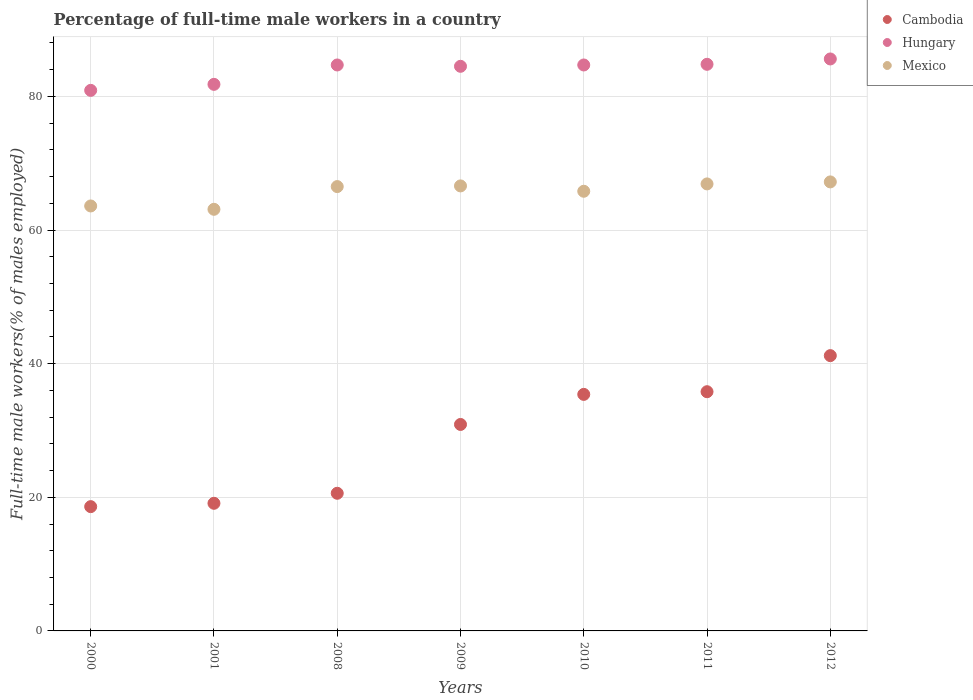Is the number of dotlines equal to the number of legend labels?
Your answer should be compact. Yes. What is the percentage of full-time male workers in Hungary in 2010?
Provide a short and direct response. 84.7. Across all years, what is the maximum percentage of full-time male workers in Cambodia?
Make the answer very short. 41.2. Across all years, what is the minimum percentage of full-time male workers in Mexico?
Keep it short and to the point. 63.1. What is the total percentage of full-time male workers in Mexico in the graph?
Provide a short and direct response. 459.7. What is the difference between the percentage of full-time male workers in Hungary in 2009 and that in 2012?
Your response must be concise. -1.1. What is the difference between the percentage of full-time male workers in Hungary in 2012 and the percentage of full-time male workers in Cambodia in 2008?
Keep it short and to the point. 65. What is the average percentage of full-time male workers in Mexico per year?
Provide a succinct answer. 65.67. In the year 2010, what is the difference between the percentage of full-time male workers in Hungary and percentage of full-time male workers in Cambodia?
Make the answer very short. 49.3. In how many years, is the percentage of full-time male workers in Hungary greater than 32 %?
Ensure brevity in your answer.  7. What is the ratio of the percentage of full-time male workers in Cambodia in 2008 to that in 2012?
Your response must be concise. 0.5. Is the percentage of full-time male workers in Mexico in 2009 less than that in 2012?
Provide a short and direct response. Yes. What is the difference between the highest and the second highest percentage of full-time male workers in Hungary?
Ensure brevity in your answer.  0.8. What is the difference between the highest and the lowest percentage of full-time male workers in Cambodia?
Your answer should be very brief. 22.6. Does the percentage of full-time male workers in Cambodia monotonically increase over the years?
Ensure brevity in your answer.  Yes. Is the percentage of full-time male workers in Hungary strictly less than the percentage of full-time male workers in Cambodia over the years?
Ensure brevity in your answer.  No. Are the values on the major ticks of Y-axis written in scientific E-notation?
Offer a terse response. No. Does the graph contain any zero values?
Offer a very short reply. No. What is the title of the graph?
Give a very brief answer. Percentage of full-time male workers in a country. What is the label or title of the Y-axis?
Make the answer very short. Full-time male workers(% of males employed). What is the Full-time male workers(% of males employed) in Cambodia in 2000?
Offer a very short reply. 18.6. What is the Full-time male workers(% of males employed) in Hungary in 2000?
Your response must be concise. 80.9. What is the Full-time male workers(% of males employed) in Mexico in 2000?
Provide a succinct answer. 63.6. What is the Full-time male workers(% of males employed) of Cambodia in 2001?
Keep it short and to the point. 19.1. What is the Full-time male workers(% of males employed) of Hungary in 2001?
Offer a very short reply. 81.8. What is the Full-time male workers(% of males employed) of Mexico in 2001?
Give a very brief answer. 63.1. What is the Full-time male workers(% of males employed) in Cambodia in 2008?
Offer a very short reply. 20.6. What is the Full-time male workers(% of males employed) of Hungary in 2008?
Provide a succinct answer. 84.7. What is the Full-time male workers(% of males employed) in Mexico in 2008?
Your answer should be very brief. 66.5. What is the Full-time male workers(% of males employed) in Cambodia in 2009?
Offer a terse response. 30.9. What is the Full-time male workers(% of males employed) in Hungary in 2009?
Your answer should be very brief. 84.5. What is the Full-time male workers(% of males employed) in Mexico in 2009?
Keep it short and to the point. 66.6. What is the Full-time male workers(% of males employed) of Cambodia in 2010?
Make the answer very short. 35.4. What is the Full-time male workers(% of males employed) in Hungary in 2010?
Provide a succinct answer. 84.7. What is the Full-time male workers(% of males employed) of Mexico in 2010?
Ensure brevity in your answer.  65.8. What is the Full-time male workers(% of males employed) in Cambodia in 2011?
Your answer should be compact. 35.8. What is the Full-time male workers(% of males employed) of Hungary in 2011?
Your response must be concise. 84.8. What is the Full-time male workers(% of males employed) in Mexico in 2011?
Give a very brief answer. 66.9. What is the Full-time male workers(% of males employed) in Cambodia in 2012?
Keep it short and to the point. 41.2. What is the Full-time male workers(% of males employed) in Hungary in 2012?
Ensure brevity in your answer.  85.6. What is the Full-time male workers(% of males employed) in Mexico in 2012?
Provide a short and direct response. 67.2. Across all years, what is the maximum Full-time male workers(% of males employed) in Cambodia?
Offer a very short reply. 41.2. Across all years, what is the maximum Full-time male workers(% of males employed) of Hungary?
Ensure brevity in your answer.  85.6. Across all years, what is the maximum Full-time male workers(% of males employed) in Mexico?
Provide a short and direct response. 67.2. Across all years, what is the minimum Full-time male workers(% of males employed) in Cambodia?
Offer a very short reply. 18.6. Across all years, what is the minimum Full-time male workers(% of males employed) of Hungary?
Offer a terse response. 80.9. Across all years, what is the minimum Full-time male workers(% of males employed) in Mexico?
Ensure brevity in your answer.  63.1. What is the total Full-time male workers(% of males employed) in Cambodia in the graph?
Provide a short and direct response. 201.6. What is the total Full-time male workers(% of males employed) of Hungary in the graph?
Provide a short and direct response. 587. What is the total Full-time male workers(% of males employed) of Mexico in the graph?
Offer a terse response. 459.7. What is the difference between the Full-time male workers(% of males employed) in Cambodia in 2000 and that in 2001?
Your answer should be very brief. -0.5. What is the difference between the Full-time male workers(% of males employed) of Mexico in 2000 and that in 2001?
Ensure brevity in your answer.  0.5. What is the difference between the Full-time male workers(% of males employed) in Cambodia in 2000 and that in 2008?
Your answer should be very brief. -2. What is the difference between the Full-time male workers(% of males employed) of Hungary in 2000 and that in 2008?
Give a very brief answer. -3.8. What is the difference between the Full-time male workers(% of males employed) of Mexico in 2000 and that in 2008?
Give a very brief answer. -2.9. What is the difference between the Full-time male workers(% of males employed) of Cambodia in 2000 and that in 2009?
Keep it short and to the point. -12.3. What is the difference between the Full-time male workers(% of males employed) in Cambodia in 2000 and that in 2010?
Offer a terse response. -16.8. What is the difference between the Full-time male workers(% of males employed) in Hungary in 2000 and that in 2010?
Your answer should be compact. -3.8. What is the difference between the Full-time male workers(% of males employed) of Cambodia in 2000 and that in 2011?
Your answer should be compact. -17.2. What is the difference between the Full-time male workers(% of males employed) in Hungary in 2000 and that in 2011?
Give a very brief answer. -3.9. What is the difference between the Full-time male workers(% of males employed) of Mexico in 2000 and that in 2011?
Offer a very short reply. -3.3. What is the difference between the Full-time male workers(% of males employed) in Cambodia in 2000 and that in 2012?
Give a very brief answer. -22.6. What is the difference between the Full-time male workers(% of males employed) of Mexico in 2000 and that in 2012?
Your answer should be compact. -3.6. What is the difference between the Full-time male workers(% of males employed) of Hungary in 2001 and that in 2008?
Provide a short and direct response. -2.9. What is the difference between the Full-time male workers(% of males employed) of Mexico in 2001 and that in 2009?
Provide a short and direct response. -3.5. What is the difference between the Full-time male workers(% of males employed) in Cambodia in 2001 and that in 2010?
Offer a terse response. -16.3. What is the difference between the Full-time male workers(% of males employed) in Hungary in 2001 and that in 2010?
Ensure brevity in your answer.  -2.9. What is the difference between the Full-time male workers(% of males employed) of Cambodia in 2001 and that in 2011?
Your answer should be compact. -16.7. What is the difference between the Full-time male workers(% of males employed) of Mexico in 2001 and that in 2011?
Your answer should be very brief. -3.8. What is the difference between the Full-time male workers(% of males employed) of Cambodia in 2001 and that in 2012?
Provide a succinct answer. -22.1. What is the difference between the Full-time male workers(% of males employed) in Hungary in 2001 and that in 2012?
Provide a succinct answer. -3.8. What is the difference between the Full-time male workers(% of males employed) of Mexico in 2001 and that in 2012?
Your answer should be very brief. -4.1. What is the difference between the Full-time male workers(% of males employed) in Cambodia in 2008 and that in 2010?
Give a very brief answer. -14.8. What is the difference between the Full-time male workers(% of males employed) in Hungary in 2008 and that in 2010?
Your answer should be very brief. 0. What is the difference between the Full-time male workers(% of males employed) in Cambodia in 2008 and that in 2011?
Offer a very short reply. -15.2. What is the difference between the Full-time male workers(% of males employed) in Hungary in 2008 and that in 2011?
Ensure brevity in your answer.  -0.1. What is the difference between the Full-time male workers(% of males employed) of Mexico in 2008 and that in 2011?
Keep it short and to the point. -0.4. What is the difference between the Full-time male workers(% of males employed) of Cambodia in 2008 and that in 2012?
Make the answer very short. -20.6. What is the difference between the Full-time male workers(% of males employed) of Hungary in 2008 and that in 2012?
Offer a very short reply. -0.9. What is the difference between the Full-time male workers(% of males employed) of Cambodia in 2009 and that in 2011?
Offer a terse response. -4.9. What is the difference between the Full-time male workers(% of males employed) in Mexico in 2009 and that in 2011?
Offer a terse response. -0.3. What is the difference between the Full-time male workers(% of males employed) of Cambodia in 2009 and that in 2012?
Your answer should be very brief. -10.3. What is the difference between the Full-time male workers(% of males employed) in Mexico in 2009 and that in 2012?
Provide a succinct answer. -0.6. What is the difference between the Full-time male workers(% of males employed) of Hungary in 2010 and that in 2011?
Your answer should be compact. -0.1. What is the difference between the Full-time male workers(% of males employed) in Hungary in 2010 and that in 2012?
Make the answer very short. -0.9. What is the difference between the Full-time male workers(% of males employed) of Mexico in 2010 and that in 2012?
Offer a very short reply. -1.4. What is the difference between the Full-time male workers(% of males employed) of Hungary in 2011 and that in 2012?
Ensure brevity in your answer.  -0.8. What is the difference between the Full-time male workers(% of males employed) of Cambodia in 2000 and the Full-time male workers(% of males employed) of Hungary in 2001?
Offer a very short reply. -63.2. What is the difference between the Full-time male workers(% of males employed) of Cambodia in 2000 and the Full-time male workers(% of males employed) of Mexico in 2001?
Provide a succinct answer. -44.5. What is the difference between the Full-time male workers(% of males employed) in Hungary in 2000 and the Full-time male workers(% of males employed) in Mexico in 2001?
Keep it short and to the point. 17.8. What is the difference between the Full-time male workers(% of males employed) of Cambodia in 2000 and the Full-time male workers(% of males employed) of Hungary in 2008?
Offer a very short reply. -66.1. What is the difference between the Full-time male workers(% of males employed) in Cambodia in 2000 and the Full-time male workers(% of males employed) in Mexico in 2008?
Offer a very short reply. -47.9. What is the difference between the Full-time male workers(% of males employed) in Hungary in 2000 and the Full-time male workers(% of males employed) in Mexico in 2008?
Offer a very short reply. 14.4. What is the difference between the Full-time male workers(% of males employed) in Cambodia in 2000 and the Full-time male workers(% of males employed) in Hungary in 2009?
Make the answer very short. -65.9. What is the difference between the Full-time male workers(% of males employed) in Cambodia in 2000 and the Full-time male workers(% of males employed) in Mexico in 2009?
Keep it short and to the point. -48. What is the difference between the Full-time male workers(% of males employed) in Hungary in 2000 and the Full-time male workers(% of males employed) in Mexico in 2009?
Make the answer very short. 14.3. What is the difference between the Full-time male workers(% of males employed) in Cambodia in 2000 and the Full-time male workers(% of males employed) in Hungary in 2010?
Offer a very short reply. -66.1. What is the difference between the Full-time male workers(% of males employed) of Cambodia in 2000 and the Full-time male workers(% of males employed) of Mexico in 2010?
Ensure brevity in your answer.  -47.2. What is the difference between the Full-time male workers(% of males employed) in Hungary in 2000 and the Full-time male workers(% of males employed) in Mexico in 2010?
Your response must be concise. 15.1. What is the difference between the Full-time male workers(% of males employed) in Cambodia in 2000 and the Full-time male workers(% of males employed) in Hungary in 2011?
Provide a succinct answer. -66.2. What is the difference between the Full-time male workers(% of males employed) in Cambodia in 2000 and the Full-time male workers(% of males employed) in Mexico in 2011?
Your answer should be compact. -48.3. What is the difference between the Full-time male workers(% of males employed) in Cambodia in 2000 and the Full-time male workers(% of males employed) in Hungary in 2012?
Provide a short and direct response. -67. What is the difference between the Full-time male workers(% of males employed) of Cambodia in 2000 and the Full-time male workers(% of males employed) of Mexico in 2012?
Your answer should be very brief. -48.6. What is the difference between the Full-time male workers(% of males employed) in Cambodia in 2001 and the Full-time male workers(% of males employed) in Hungary in 2008?
Keep it short and to the point. -65.6. What is the difference between the Full-time male workers(% of males employed) of Cambodia in 2001 and the Full-time male workers(% of males employed) of Mexico in 2008?
Give a very brief answer. -47.4. What is the difference between the Full-time male workers(% of males employed) in Hungary in 2001 and the Full-time male workers(% of males employed) in Mexico in 2008?
Your response must be concise. 15.3. What is the difference between the Full-time male workers(% of males employed) of Cambodia in 2001 and the Full-time male workers(% of males employed) of Hungary in 2009?
Your response must be concise. -65.4. What is the difference between the Full-time male workers(% of males employed) in Cambodia in 2001 and the Full-time male workers(% of males employed) in Mexico in 2009?
Ensure brevity in your answer.  -47.5. What is the difference between the Full-time male workers(% of males employed) in Hungary in 2001 and the Full-time male workers(% of males employed) in Mexico in 2009?
Provide a short and direct response. 15.2. What is the difference between the Full-time male workers(% of males employed) of Cambodia in 2001 and the Full-time male workers(% of males employed) of Hungary in 2010?
Make the answer very short. -65.6. What is the difference between the Full-time male workers(% of males employed) of Cambodia in 2001 and the Full-time male workers(% of males employed) of Mexico in 2010?
Your answer should be very brief. -46.7. What is the difference between the Full-time male workers(% of males employed) of Hungary in 2001 and the Full-time male workers(% of males employed) of Mexico in 2010?
Offer a very short reply. 16. What is the difference between the Full-time male workers(% of males employed) of Cambodia in 2001 and the Full-time male workers(% of males employed) of Hungary in 2011?
Offer a very short reply. -65.7. What is the difference between the Full-time male workers(% of males employed) in Cambodia in 2001 and the Full-time male workers(% of males employed) in Mexico in 2011?
Give a very brief answer. -47.8. What is the difference between the Full-time male workers(% of males employed) in Cambodia in 2001 and the Full-time male workers(% of males employed) in Hungary in 2012?
Your answer should be very brief. -66.5. What is the difference between the Full-time male workers(% of males employed) in Cambodia in 2001 and the Full-time male workers(% of males employed) in Mexico in 2012?
Provide a succinct answer. -48.1. What is the difference between the Full-time male workers(% of males employed) of Hungary in 2001 and the Full-time male workers(% of males employed) of Mexico in 2012?
Provide a succinct answer. 14.6. What is the difference between the Full-time male workers(% of males employed) of Cambodia in 2008 and the Full-time male workers(% of males employed) of Hungary in 2009?
Ensure brevity in your answer.  -63.9. What is the difference between the Full-time male workers(% of males employed) in Cambodia in 2008 and the Full-time male workers(% of males employed) in Mexico in 2009?
Your response must be concise. -46. What is the difference between the Full-time male workers(% of males employed) in Cambodia in 2008 and the Full-time male workers(% of males employed) in Hungary in 2010?
Your answer should be very brief. -64.1. What is the difference between the Full-time male workers(% of males employed) in Cambodia in 2008 and the Full-time male workers(% of males employed) in Mexico in 2010?
Ensure brevity in your answer.  -45.2. What is the difference between the Full-time male workers(% of males employed) in Hungary in 2008 and the Full-time male workers(% of males employed) in Mexico in 2010?
Your answer should be very brief. 18.9. What is the difference between the Full-time male workers(% of males employed) in Cambodia in 2008 and the Full-time male workers(% of males employed) in Hungary in 2011?
Ensure brevity in your answer.  -64.2. What is the difference between the Full-time male workers(% of males employed) of Cambodia in 2008 and the Full-time male workers(% of males employed) of Mexico in 2011?
Your answer should be compact. -46.3. What is the difference between the Full-time male workers(% of males employed) in Cambodia in 2008 and the Full-time male workers(% of males employed) in Hungary in 2012?
Keep it short and to the point. -65. What is the difference between the Full-time male workers(% of males employed) of Cambodia in 2008 and the Full-time male workers(% of males employed) of Mexico in 2012?
Offer a very short reply. -46.6. What is the difference between the Full-time male workers(% of males employed) of Cambodia in 2009 and the Full-time male workers(% of males employed) of Hungary in 2010?
Ensure brevity in your answer.  -53.8. What is the difference between the Full-time male workers(% of males employed) of Cambodia in 2009 and the Full-time male workers(% of males employed) of Mexico in 2010?
Your response must be concise. -34.9. What is the difference between the Full-time male workers(% of males employed) in Hungary in 2009 and the Full-time male workers(% of males employed) in Mexico in 2010?
Provide a short and direct response. 18.7. What is the difference between the Full-time male workers(% of males employed) of Cambodia in 2009 and the Full-time male workers(% of males employed) of Hungary in 2011?
Provide a short and direct response. -53.9. What is the difference between the Full-time male workers(% of males employed) of Cambodia in 2009 and the Full-time male workers(% of males employed) of Mexico in 2011?
Offer a terse response. -36. What is the difference between the Full-time male workers(% of males employed) in Cambodia in 2009 and the Full-time male workers(% of males employed) in Hungary in 2012?
Provide a short and direct response. -54.7. What is the difference between the Full-time male workers(% of males employed) of Cambodia in 2009 and the Full-time male workers(% of males employed) of Mexico in 2012?
Keep it short and to the point. -36.3. What is the difference between the Full-time male workers(% of males employed) in Cambodia in 2010 and the Full-time male workers(% of males employed) in Hungary in 2011?
Your answer should be very brief. -49.4. What is the difference between the Full-time male workers(% of males employed) of Cambodia in 2010 and the Full-time male workers(% of males employed) of Mexico in 2011?
Your answer should be compact. -31.5. What is the difference between the Full-time male workers(% of males employed) in Cambodia in 2010 and the Full-time male workers(% of males employed) in Hungary in 2012?
Provide a short and direct response. -50.2. What is the difference between the Full-time male workers(% of males employed) of Cambodia in 2010 and the Full-time male workers(% of males employed) of Mexico in 2012?
Your answer should be compact. -31.8. What is the difference between the Full-time male workers(% of males employed) of Hungary in 2010 and the Full-time male workers(% of males employed) of Mexico in 2012?
Keep it short and to the point. 17.5. What is the difference between the Full-time male workers(% of males employed) in Cambodia in 2011 and the Full-time male workers(% of males employed) in Hungary in 2012?
Offer a very short reply. -49.8. What is the difference between the Full-time male workers(% of males employed) of Cambodia in 2011 and the Full-time male workers(% of males employed) of Mexico in 2012?
Provide a succinct answer. -31.4. What is the average Full-time male workers(% of males employed) of Cambodia per year?
Give a very brief answer. 28.8. What is the average Full-time male workers(% of males employed) of Hungary per year?
Ensure brevity in your answer.  83.86. What is the average Full-time male workers(% of males employed) in Mexico per year?
Provide a succinct answer. 65.67. In the year 2000, what is the difference between the Full-time male workers(% of males employed) in Cambodia and Full-time male workers(% of males employed) in Hungary?
Make the answer very short. -62.3. In the year 2000, what is the difference between the Full-time male workers(% of males employed) of Cambodia and Full-time male workers(% of males employed) of Mexico?
Your response must be concise. -45. In the year 2001, what is the difference between the Full-time male workers(% of males employed) in Cambodia and Full-time male workers(% of males employed) in Hungary?
Make the answer very short. -62.7. In the year 2001, what is the difference between the Full-time male workers(% of males employed) in Cambodia and Full-time male workers(% of males employed) in Mexico?
Your response must be concise. -44. In the year 2008, what is the difference between the Full-time male workers(% of males employed) in Cambodia and Full-time male workers(% of males employed) in Hungary?
Give a very brief answer. -64.1. In the year 2008, what is the difference between the Full-time male workers(% of males employed) in Cambodia and Full-time male workers(% of males employed) in Mexico?
Your response must be concise. -45.9. In the year 2009, what is the difference between the Full-time male workers(% of males employed) in Cambodia and Full-time male workers(% of males employed) in Hungary?
Your answer should be very brief. -53.6. In the year 2009, what is the difference between the Full-time male workers(% of males employed) of Cambodia and Full-time male workers(% of males employed) of Mexico?
Your answer should be compact. -35.7. In the year 2009, what is the difference between the Full-time male workers(% of males employed) of Hungary and Full-time male workers(% of males employed) of Mexico?
Your answer should be very brief. 17.9. In the year 2010, what is the difference between the Full-time male workers(% of males employed) of Cambodia and Full-time male workers(% of males employed) of Hungary?
Offer a terse response. -49.3. In the year 2010, what is the difference between the Full-time male workers(% of males employed) of Cambodia and Full-time male workers(% of males employed) of Mexico?
Offer a terse response. -30.4. In the year 2010, what is the difference between the Full-time male workers(% of males employed) in Hungary and Full-time male workers(% of males employed) in Mexico?
Provide a succinct answer. 18.9. In the year 2011, what is the difference between the Full-time male workers(% of males employed) in Cambodia and Full-time male workers(% of males employed) in Hungary?
Ensure brevity in your answer.  -49. In the year 2011, what is the difference between the Full-time male workers(% of males employed) in Cambodia and Full-time male workers(% of males employed) in Mexico?
Your answer should be very brief. -31.1. In the year 2011, what is the difference between the Full-time male workers(% of males employed) of Hungary and Full-time male workers(% of males employed) of Mexico?
Your answer should be compact. 17.9. In the year 2012, what is the difference between the Full-time male workers(% of males employed) of Cambodia and Full-time male workers(% of males employed) of Hungary?
Make the answer very short. -44.4. What is the ratio of the Full-time male workers(% of males employed) in Cambodia in 2000 to that in 2001?
Offer a very short reply. 0.97. What is the ratio of the Full-time male workers(% of males employed) of Hungary in 2000 to that in 2001?
Offer a terse response. 0.99. What is the ratio of the Full-time male workers(% of males employed) in Mexico in 2000 to that in 2001?
Your answer should be very brief. 1.01. What is the ratio of the Full-time male workers(% of males employed) in Cambodia in 2000 to that in 2008?
Ensure brevity in your answer.  0.9. What is the ratio of the Full-time male workers(% of males employed) in Hungary in 2000 to that in 2008?
Offer a very short reply. 0.96. What is the ratio of the Full-time male workers(% of males employed) of Mexico in 2000 to that in 2008?
Keep it short and to the point. 0.96. What is the ratio of the Full-time male workers(% of males employed) of Cambodia in 2000 to that in 2009?
Give a very brief answer. 0.6. What is the ratio of the Full-time male workers(% of males employed) of Hungary in 2000 to that in 2009?
Give a very brief answer. 0.96. What is the ratio of the Full-time male workers(% of males employed) of Mexico in 2000 to that in 2009?
Your answer should be compact. 0.95. What is the ratio of the Full-time male workers(% of males employed) of Cambodia in 2000 to that in 2010?
Provide a succinct answer. 0.53. What is the ratio of the Full-time male workers(% of males employed) in Hungary in 2000 to that in 2010?
Provide a succinct answer. 0.96. What is the ratio of the Full-time male workers(% of males employed) of Mexico in 2000 to that in 2010?
Keep it short and to the point. 0.97. What is the ratio of the Full-time male workers(% of males employed) in Cambodia in 2000 to that in 2011?
Give a very brief answer. 0.52. What is the ratio of the Full-time male workers(% of males employed) of Hungary in 2000 to that in 2011?
Your response must be concise. 0.95. What is the ratio of the Full-time male workers(% of males employed) in Mexico in 2000 to that in 2011?
Ensure brevity in your answer.  0.95. What is the ratio of the Full-time male workers(% of males employed) of Cambodia in 2000 to that in 2012?
Your response must be concise. 0.45. What is the ratio of the Full-time male workers(% of males employed) of Hungary in 2000 to that in 2012?
Your response must be concise. 0.95. What is the ratio of the Full-time male workers(% of males employed) of Mexico in 2000 to that in 2012?
Offer a terse response. 0.95. What is the ratio of the Full-time male workers(% of males employed) in Cambodia in 2001 to that in 2008?
Your answer should be very brief. 0.93. What is the ratio of the Full-time male workers(% of males employed) of Hungary in 2001 to that in 2008?
Give a very brief answer. 0.97. What is the ratio of the Full-time male workers(% of males employed) of Mexico in 2001 to that in 2008?
Your answer should be compact. 0.95. What is the ratio of the Full-time male workers(% of males employed) of Cambodia in 2001 to that in 2009?
Your response must be concise. 0.62. What is the ratio of the Full-time male workers(% of males employed) of Cambodia in 2001 to that in 2010?
Your answer should be compact. 0.54. What is the ratio of the Full-time male workers(% of males employed) of Hungary in 2001 to that in 2010?
Ensure brevity in your answer.  0.97. What is the ratio of the Full-time male workers(% of males employed) in Mexico in 2001 to that in 2010?
Provide a short and direct response. 0.96. What is the ratio of the Full-time male workers(% of males employed) in Cambodia in 2001 to that in 2011?
Provide a succinct answer. 0.53. What is the ratio of the Full-time male workers(% of males employed) of Hungary in 2001 to that in 2011?
Keep it short and to the point. 0.96. What is the ratio of the Full-time male workers(% of males employed) in Mexico in 2001 to that in 2011?
Make the answer very short. 0.94. What is the ratio of the Full-time male workers(% of males employed) of Cambodia in 2001 to that in 2012?
Ensure brevity in your answer.  0.46. What is the ratio of the Full-time male workers(% of males employed) in Hungary in 2001 to that in 2012?
Provide a short and direct response. 0.96. What is the ratio of the Full-time male workers(% of males employed) of Mexico in 2001 to that in 2012?
Make the answer very short. 0.94. What is the ratio of the Full-time male workers(% of males employed) of Cambodia in 2008 to that in 2009?
Ensure brevity in your answer.  0.67. What is the ratio of the Full-time male workers(% of males employed) in Mexico in 2008 to that in 2009?
Keep it short and to the point. 1. What is the ratio of the Full-time male workers(% of males employed) of Cambodia in 2008 to that in 2010?
Your answer should be compact. 0.58. What is the ratio of the Full-time male workers(% of males employed) of Hungary in 2008 to that in 2010?
Ensure brevity in your answer.  1. What is the ratio of the Full-time male workers(% of males employed) in Mexico in 2008 to that in 2010?
Provide a succinct answer. 1.01. What is the ratio of the Full-time male workers(% of males employed) in Cambodia in 2008 to that in 2011?
Offer a very short reply. 0.58. What is the ratio of the Full-time male workers(% of males employed) in Hungary in 2008 to that in 2011?
Provide a succinct answer. 1. What is the ratio of the Full-time male workers(% of males employed) in Cambodia in 2008 to that in 2012?
Keep it short and to the point. 0.5. What is the ratio of the Full-time male workers(% of males employed) of Cambodia in 2009 to that in 2010?
Give a very brief answer. 0.87. What is the ratio of the Full-time male workers(% of males employed) in Hungary in 2009 to that in 2010?
Offer a terse response. 1. What is the ratio of the Full-time male workers(% of males employed) of Mexico in 2009 to that in 2010?
Give a very brief answer. 1.01. What is the ratio of the Full-time male workers(% of males employed) in Cambodia in 2009 to that in 2011?
Your response must be concise. 0.86. What is the ratio of the Full-time male workers(% of males employed) in Hungary in 2009 to that in 2011?
Make the answer very short. 1. What is the ratio of the Full-time male workers(% of males employed) in Mexico in 2009 to that in 2011?
Provide a succinct answer. 1. What is the ratio of the Full-time male workers(% of males employed) of Hungary in 2009 to that in 2012?
Offer a very short reply. 0.99. What is the ratio of the Full-time male workers(% of males employed) in Mexico in 2010 to that in 2011?
Give a very brief answer. 0.98. What is the ratio of the Full-time male workers(% of males employed) in Cambodia in 2010 to that in 2012?
Your response must be concise. 0.86. What is the ratio of the Full-time male workers(% of males employed) in Hungary in 2010 to that in 2012?
Offer a terse response. 0.99. What is the ratio of the Full-time male workers(% of males employed) of Mexico in 2010 to that in 2012?
Give a very brief answer. 0.98. What is the ratio of the Full-time male workers(% of males employed) of Cambodia in 2011 to that in 2012?
Keep it short and to the point. 0.87. What is the difference between the highest and the second highest Full-time male workers(% of males employed) in Cambodia?
Offer a very short reply. 5.4. What is the difference between the highest and the lowest Full-time male workers(% of males employed) in Cambodia?
Ensure brevity in your answer.  22.6. What is the difference between the highest and the lowest Full-time male workers(% of males employed) in Hungary?
Ensure brevity in your answer.  4.7. What is the difference between the highest and the lowest Full-time male workers(% of males employed) of Mexico?
Make the answer very short. 4.1. 